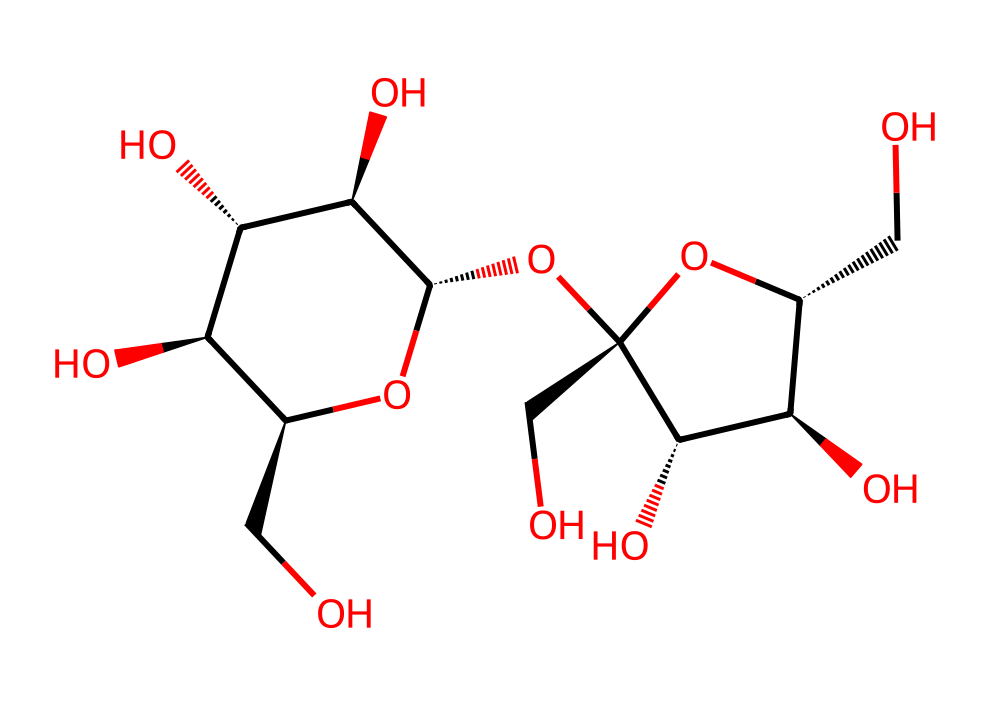How many carbon atoms are in this compound? Count the carbon atoms represented by 'C' in the SMILES notation. Each 'C' corresponds to a carbon atom, and reviewing the structure reveals there are nine carbon atoms in total.
Answer: nine What is the primary functional group present in this compound? Analyze the structure for the presence of functional groups. The presence of multiple 'O's connected in a way indicative of hydroxyl (alcohol) groups suggests that it contains alcohol functional groups.
Answer: alcohol How many hydroxyl groups are attached to the carbon skeleton? Count the number of 'O' atoms connected to 'C' in the structure that fulfill the conditions of hydroxyl groups. Observing the chemical, there are six 'O's bonded to carbon atoms, indicating six hydroxyl groups.
Answer: six Which stereogenic centers can be identified within this chemical structure? Examine the structure for chiral centers, which occur at carbons bonded to four different substituents. In this compound, there are five carbons with multiple attachments, revealing five stereogenic centers.
Answer: five Is this compound likely to be soluble in water? Consider the presence of hydroxyl groups, which are polar and can create hydrogen bonds with water molecules. The presence of multiple hydroxyl groups suggests high water solubility.
Answer: yes What type of compound is beet sugar categorized as? Identify the classification of the compound by focusing on the number of sugar units present. Given the multiple hydroxyl groups and specific carbon arrangement, this compound is categorized as a sugar (specifically a disaccharide).
Answer: sugar 